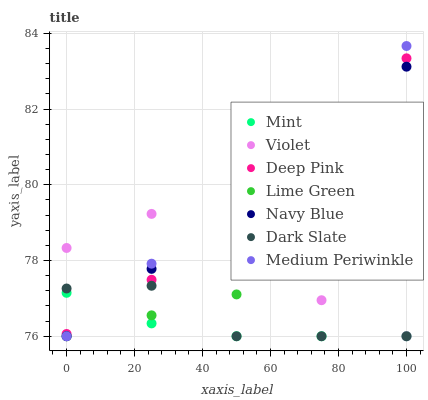Does Mint have the minimum area under the curve?
Answer yes or no. Yes. Does Medium Periwinkle have the maximum area under the curve?
Answer yes or no. Yes. Does Navy Blue have the minimum area under the curve?
Answer yes or no. No. Does Navy Blue have the maximum area under the curve?
Answer yes or no. No. Is Lime Green the smoothest?
Answer yes or no. Yes. Is Violet the roughest?
Answer yes or no. Yes. Is Navy Blue the smoothest?
Answer yes or no. No. Is Navy Blue the roughest?
Answer yes or no. No. Does Navy Blue have the lowest value?
Answer yes or no. Yes. Does Medium Periwinkle have the highest value?
Answer yes or no. Yes. Does Navy Blue have the highest value?
Answer yes or no. No. Is Lime Green less than Deep Pink?
Answer yes or no. Yes. Is Deep Pink greater than Lime Green?
Answer yes or no. Yes. Does Dark Slate intersect Medium Periwinkle?
Answer yes or no. Yes. Is Dark Slate less than Medium Periwinkle?
Answer yes or no. No. Is Dark Slate greater than Medium Periwinkle?
Answer yes or no. No. Does Lime Green intersect Deep Pink?
Answer yes or no. No. 